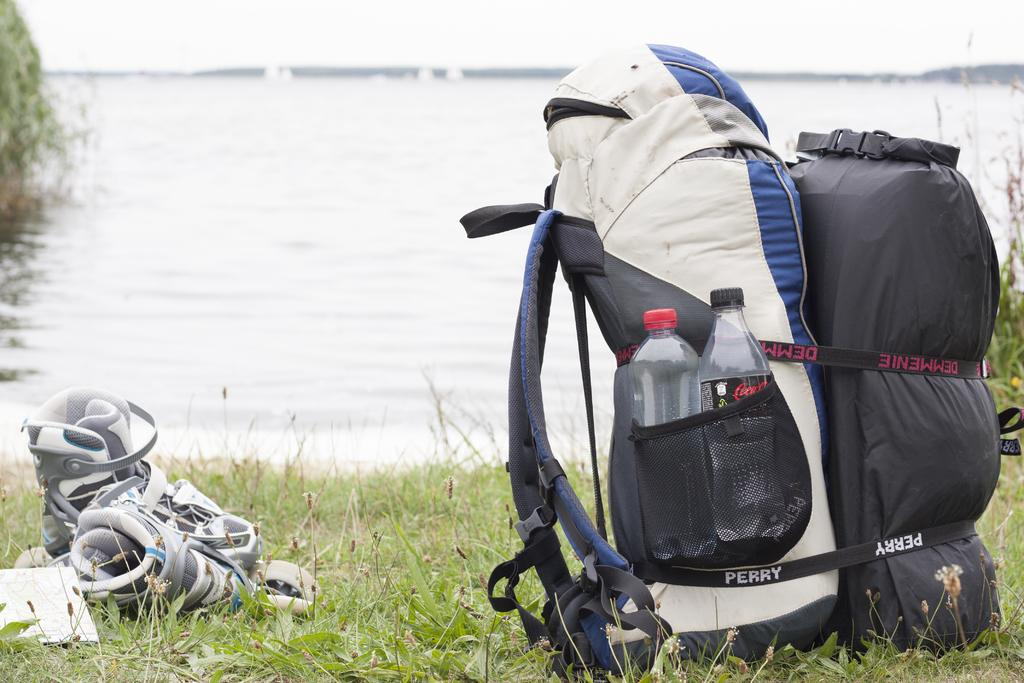Provide a one-sentence caption for the provided image. The two straps on a backpack and sleeping bag read Perry and Demmenie. 